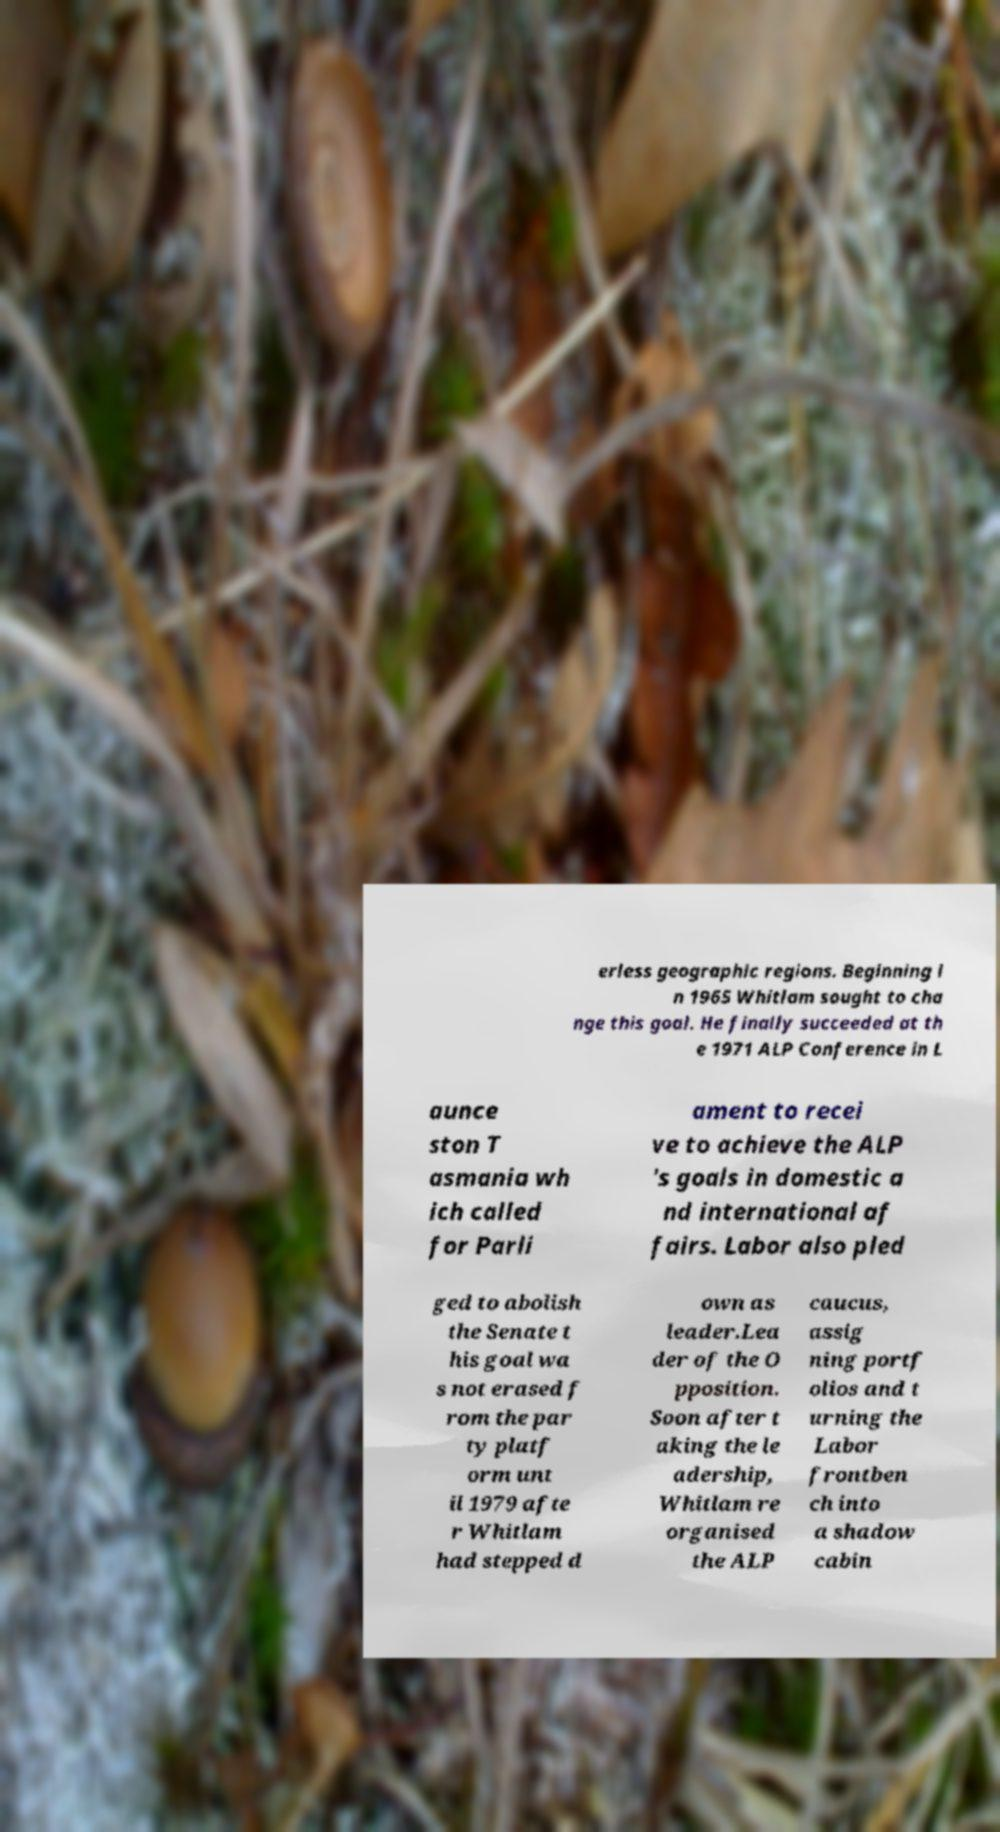Could you extract and type out the text from this image? erless geographic regions. Beginning i n 1965 Whitlam sought to cha nge this goal. He finally succeeded at th e 1971 ALP Conference in L aunce ston T asmania wh ich called for Parli ament to recei ve to achieve the ALP 's goals in domestic a nd international af fairs. Labor also pled ged to abolish the Senate t his goal wa s not erased f rom the par ty platf orm unt il 1979 afte r Whitlam had stepped d own as leader.Lea der of the O pposition. Soon after t aking the le adership, Whitlam re organised the ALP caucus, assig ning portf olios and t urning the Labor frontben ch into a shadow cabin 